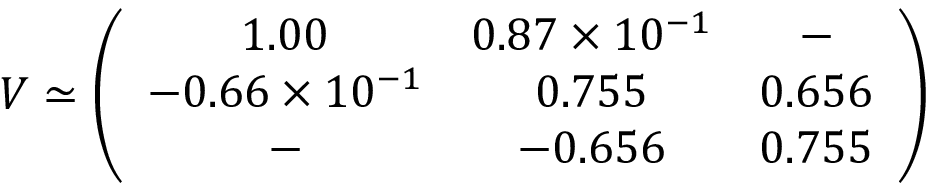<formula> <loc_0><loc_0><loc_500><loc_500>V \simeq \left ( \begin{array} { c c c } { 1 . 0 0 } & { { 0 . 8 7 \times 1 0 ^ { - 1 } } } & { - } \\ { { - 0 . 6 6 \times 1 0 ^ { - 1 } } } & { 0 . 7 5 5 } & { 0 . 6 5 6 } \\ { - } & { - 0 . 6 5 6 } & { 0 . 7 5 5 } \end{array} \right )</formula> 